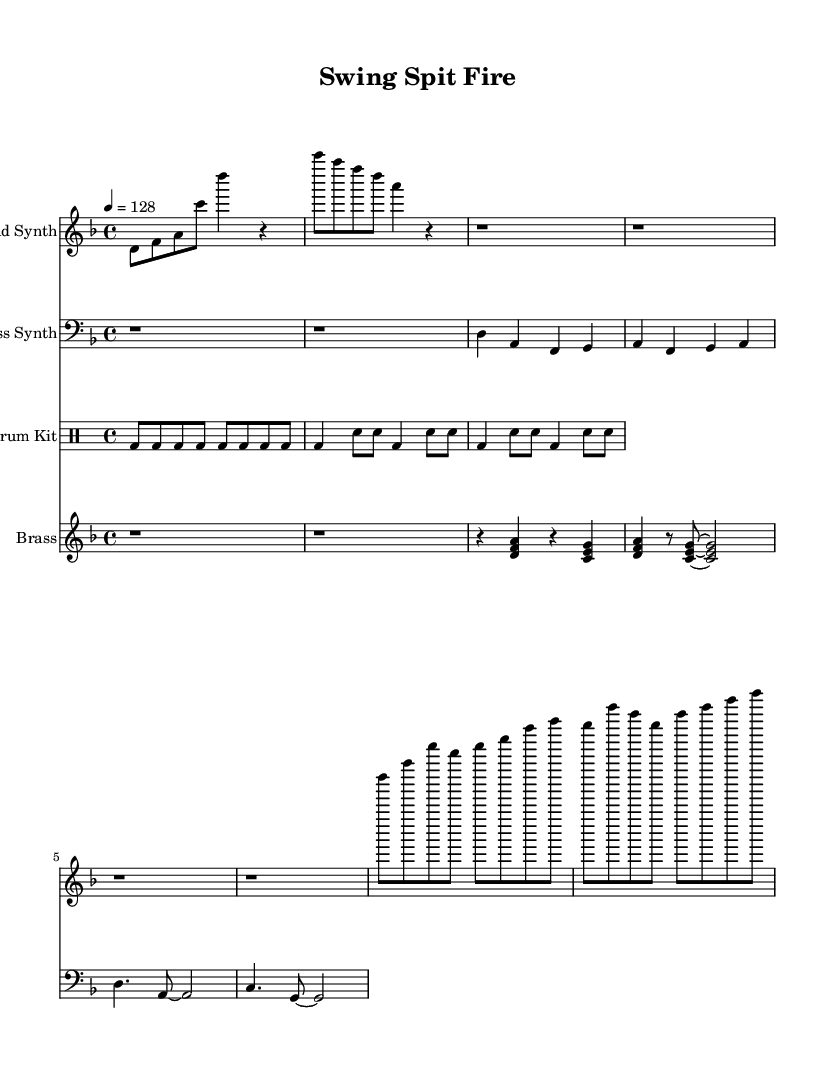What is the key signature of this music? The key signature indicated at the beginning of the staff shows two flats, which is characteristic of D minor.
Answer: D minor What is the time signature of this piece? The time signature displayed at the start of the score is 4/4, which means there are four beats in each measure and the quarter note gets one beat.
Answer: 4/4 What is the tempo marking for this composition? The tempo marking at the beginning shows a metronome setting of 128 beats per minute, indicating a moderate tempo that drives the piece forward.
Answer: 128 What instruments are included in this score? The score contains four distinct instrumental parts: Lead Synth, Bass Synth, Drum Kit, and Brass. Each has its own staff for a clear layout.
Answer: Lead Synth, Bass Synth, Drum Kit, Brass How many measures are present in the Lead Synth part? By counting the groups of notes and rests, we find that there are a total of eight measures in the Lead Synth part.
Answer: Eight Which rhythmic pattern dominates the Drum Kit section? The Drum Kit section predominantly features a consistent kick drum rhythm, shown by the presence of eight consecutive kick notes followed by a variation of snare hits.
Answer: Kick drum What is unique about the brass section's rhythm compared to the other parts? The brass section has a distinct stop-and-go feel with rests that separate the rhythms, giving it a contrasting dynamic compared to the continuous flow of the other parts.
Answer: Stop-and-go feel 